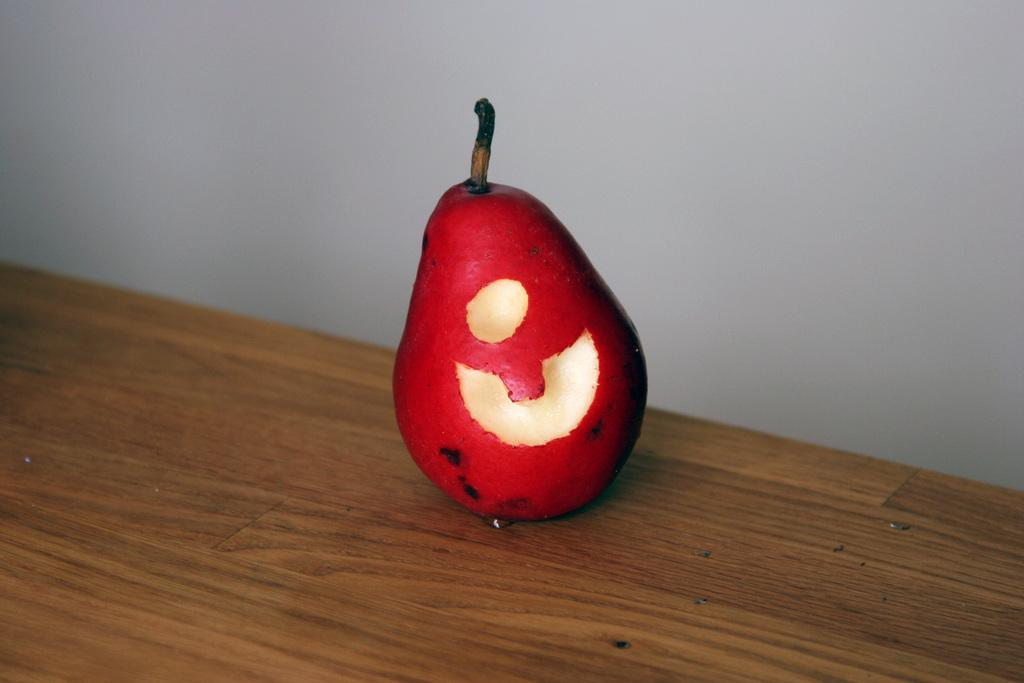What type of fruit is in the image? There is a pear fruit in the image. On what surface is the pear fruit placed? The pear fruit is on a wooden surface. What can be seen behind the fruit in the image? There is a wall visible behind the fruit. What is the tendency of the animal to play with the kitty in the image? There is no animal or kitty present in the image, so it is not possible to determine any tendencies related to them. 